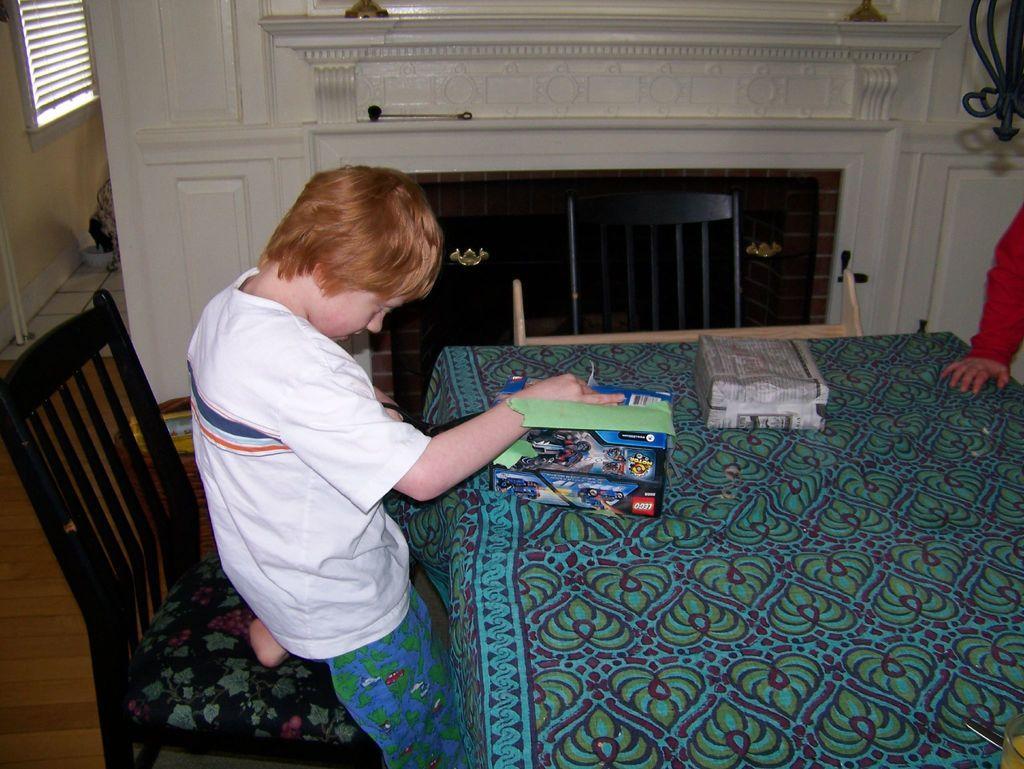Please provide a concise description of this image. The picture is taken inside a house,on a dining table cloth is placed and on that there are two boxes one is parcel the second one is a game the kid is sitting on a chair and opening the box,in the background there is a white cupboard to its left there is a window and a wall the floor is of wood. 